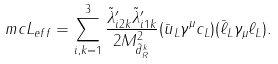<formula> <loc_0><loc_0><loc_500><loc_500>\ m c { L } _ { e f f } = \sum _ { i , k = 1 } ^ { 3 } \frac { \tilde { \lambda } ^ { \prime } _ { i 2 k } \tilde { \lambda } ^ { \prime } _ { i 1 k } } { 2 M ^ { 2 } _ { \tilde { d } _ { R } ^ { k } } } ( \bar { u } _ { L } \gamma ^ { \mu } c _ { L } ) ( \bar { \ell } _ { L } \gamma _ { \mu } \ell _ { L } ) .</formula> 